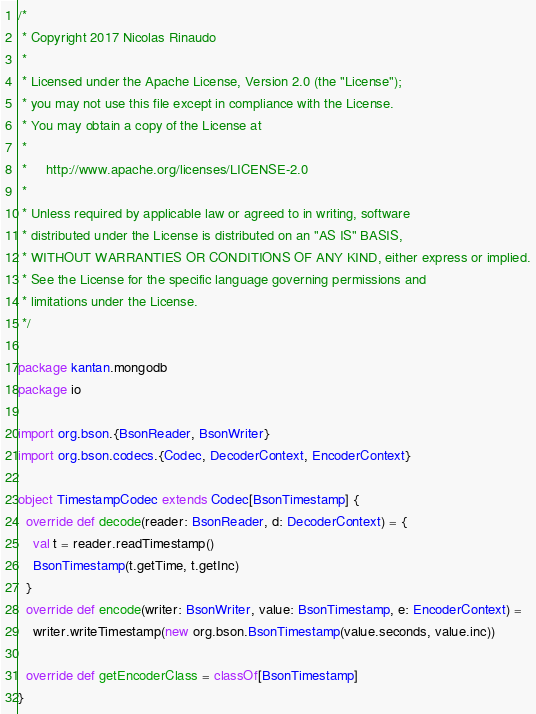<code> <loc_0><loc_0><loc_500><loc_500><_Scala_>/*
 * Copyright 2017 Nicolas Rinaudo
 *
 * Licensed under the Apache License, Version 2.0 (the "License");
 * you may not use this file except in compliance with the License.
 * You may obtain a copy of the License at
 *
 *     http://www.apache.org/licenses/LICENSE-2.0
 *
 * Unless required by applicable law or agreed to in writing, software
 * distributed under the License is distributed on an "AS IS" BASIS,
 * WITHOUT WARRANTIES OR CONDITIONS OF ANY KIND, either express or implied.
 * See the License for the specific language governing permissions and
 * limitations under the License.
 */

package kantan.mongodb
package io

import org.bson.{BsonReader, BsonWriter}
import org.bson.codecs.{Codec, DecoderContext, EncoderContext}

object TimestampCodec extends Codec[BsonTimestamp] {
  override def decode(reader: BsonReader, d: DecoderContext) = {
    val t = reader.readTimestamp()
    BsonTimestamp(t.getTime, t.getInc)
  }
  override def encode(writer: BsonWriter, value: BsonTimestamp, e: EncoderContext) =
    writer.writeTimestamp(new org.bson.BsonTimestamp(value.seconds, value.inc))

  override def getEncoderClass = classOf[BsonTimestamp]
}
</code> 